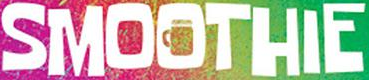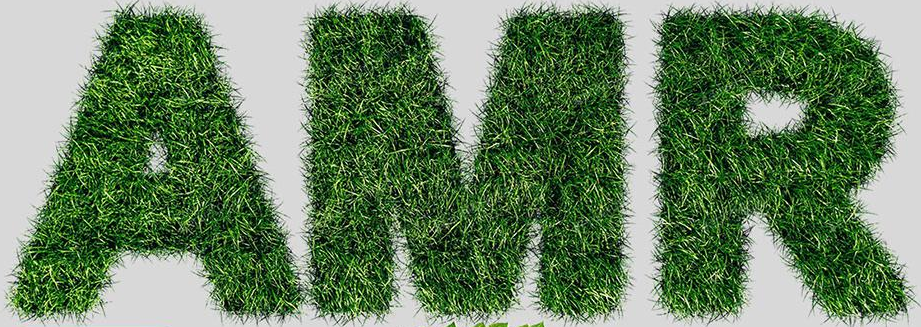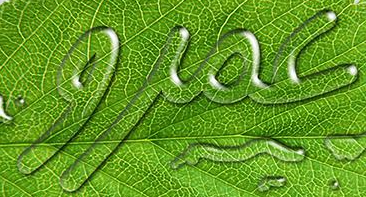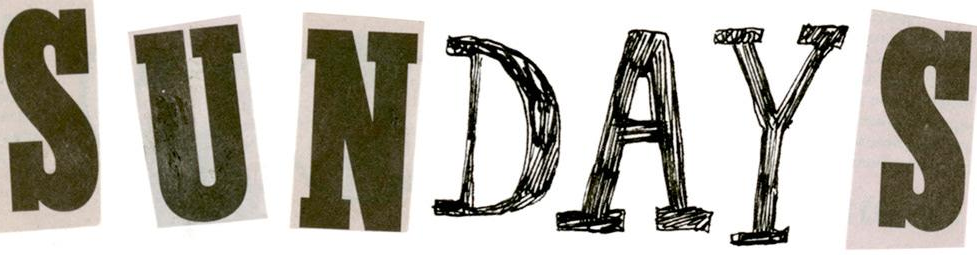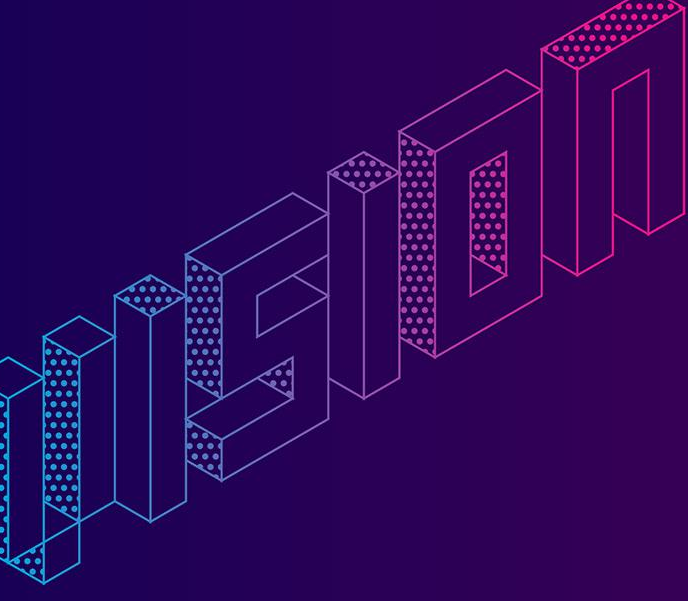Transcribe the words shown in these images in order, separated by a semicolon. SMOOTHIE; AMR; jioc; SUNDAYS; VISION 